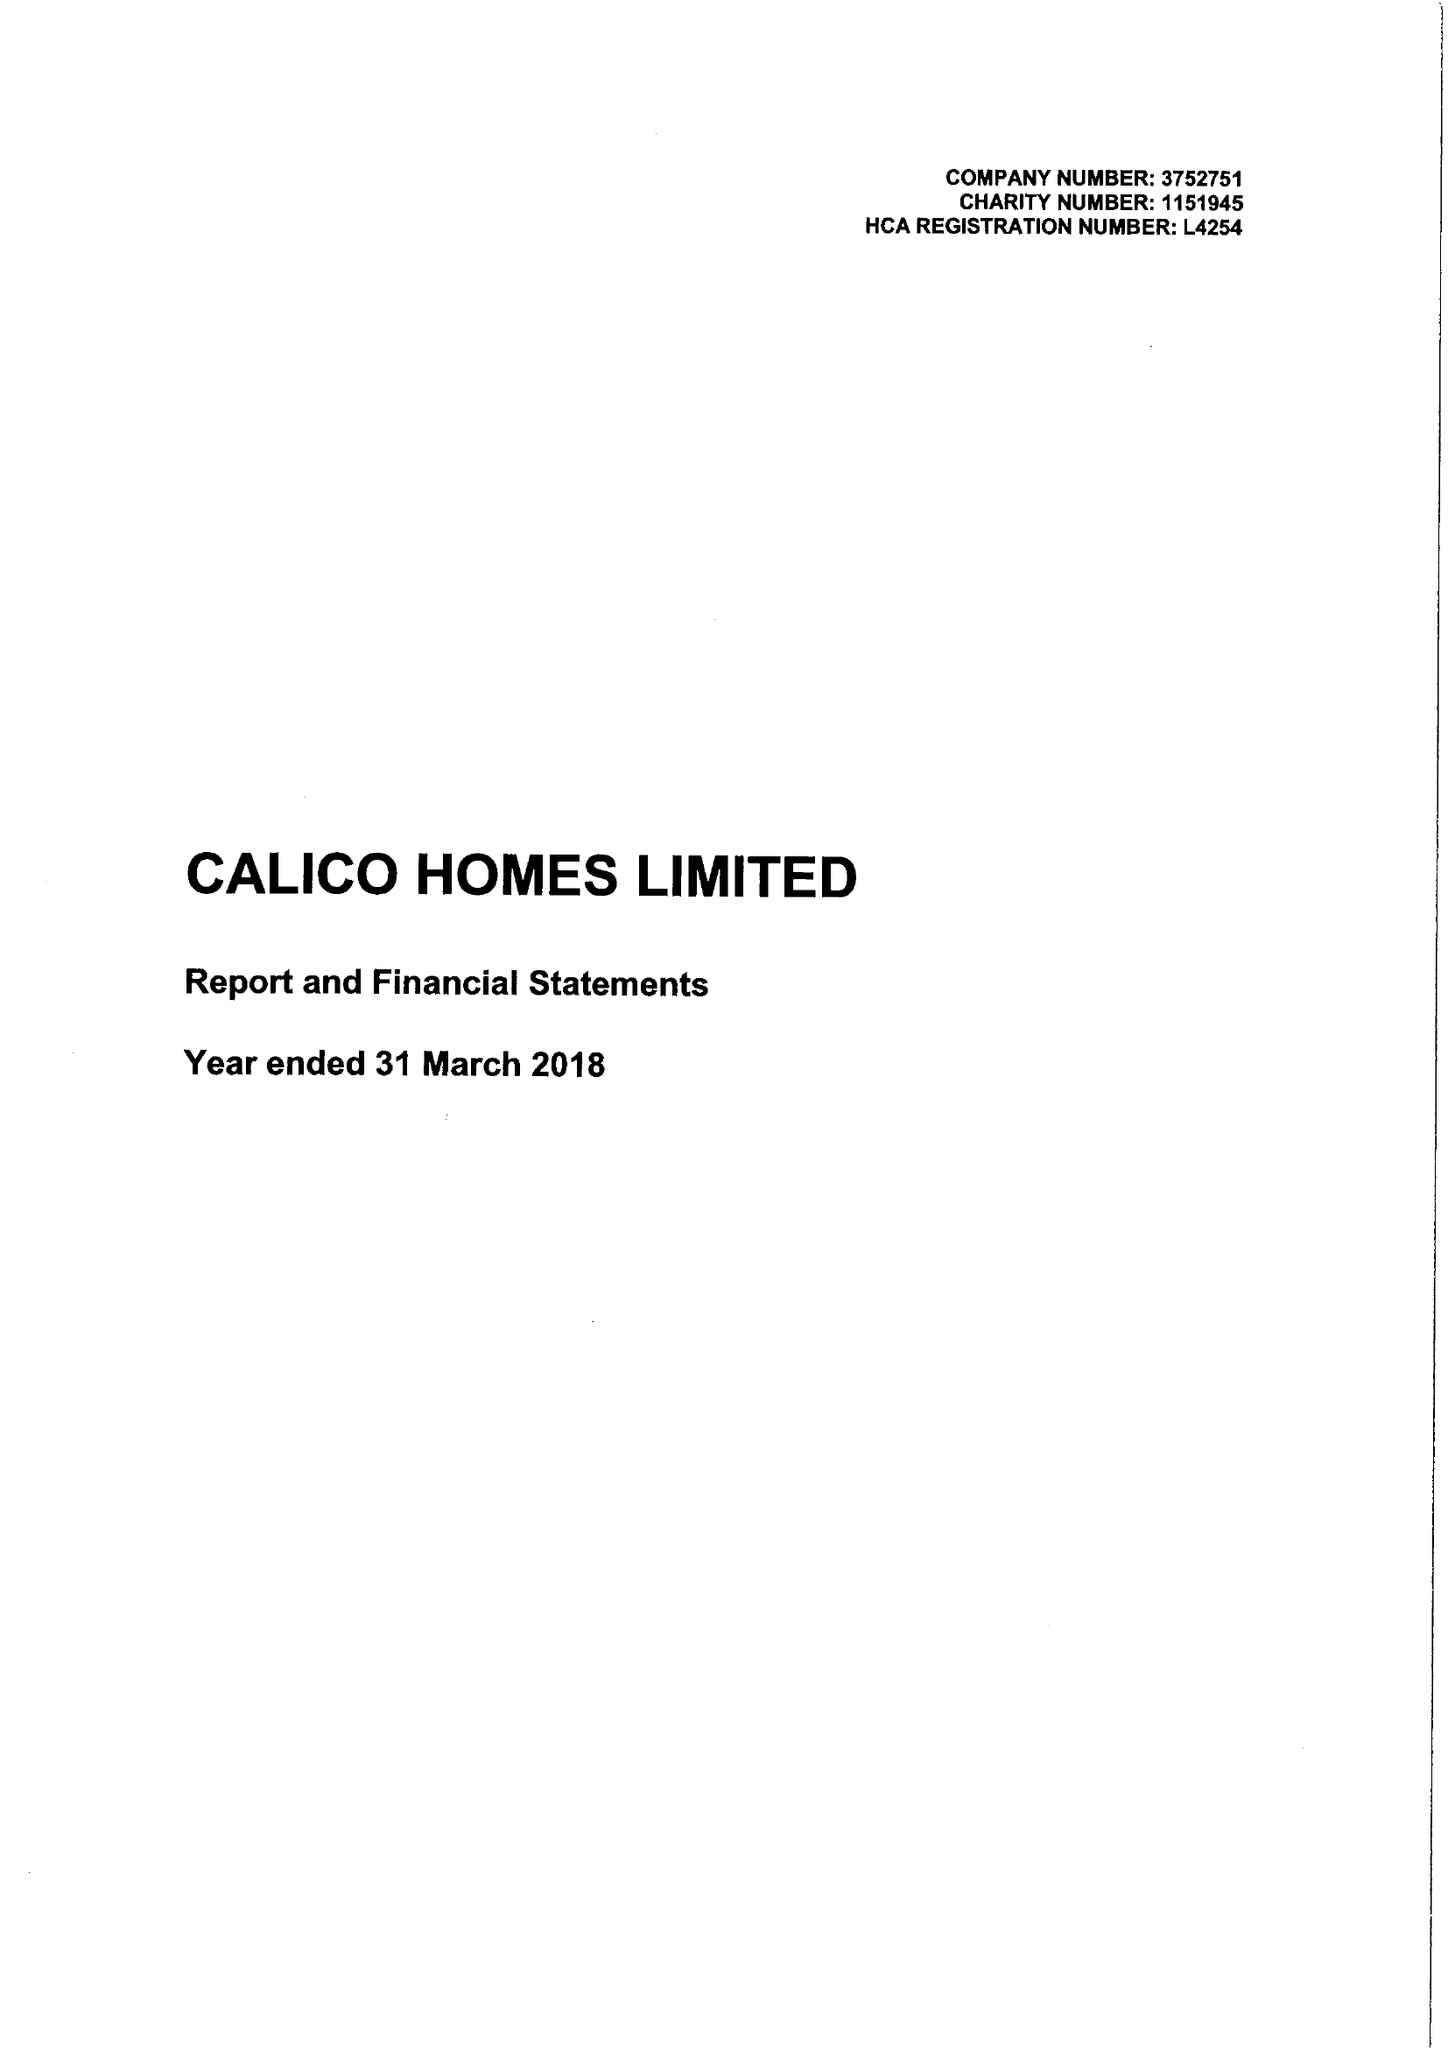What is the value for the income_annually_in_british_pounds?
Answer the question using a single word or phrase. 22396000.00 